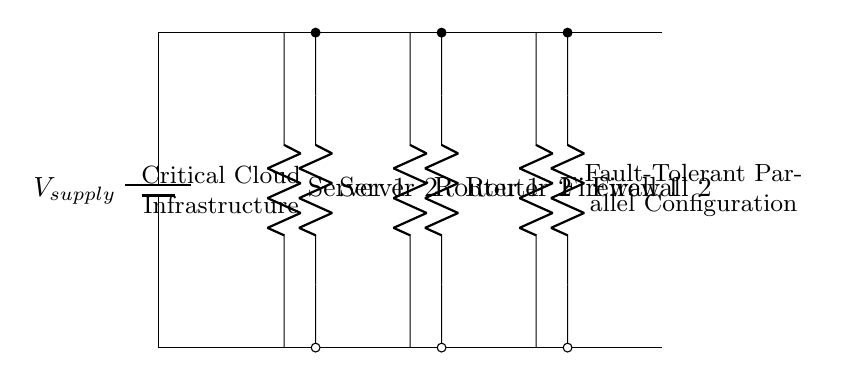What are the components in this circuit? The components are two servers, two routers, and two firewalls, all connected in parallel.
Answer: Servers, routers, firewalls What is the role of the redundant components? The redundant components serve as backups to the primary components, ensuring continued operation if one fails.
Answer: Backup How many total paths exist for current flow in this circuit? There are four paths for current flow: one for each primary component and one for each redundant component.
Answer: Four What does the voltage source provide to this circuit? The voltage source provides a constant voltage supply necessary for the operation of all components in the circuit.
Answer: Voltage supply Which component is likely to experience a failure first based on typical usage? Typically, the router might fail first due to higher network traffic and strain compared to servers or firewalls.
Answer: Router How does the configuration enhance fault tolerance? The parallel arrangement allows current to flow through multiple components; if one component fails, others can still operate, maintaining functionality.
Answer: Maintain functionality What is the total number of components in this parallel configuration? There are six total components: two servers, two routers, and two firewalls.
Answer: Six 